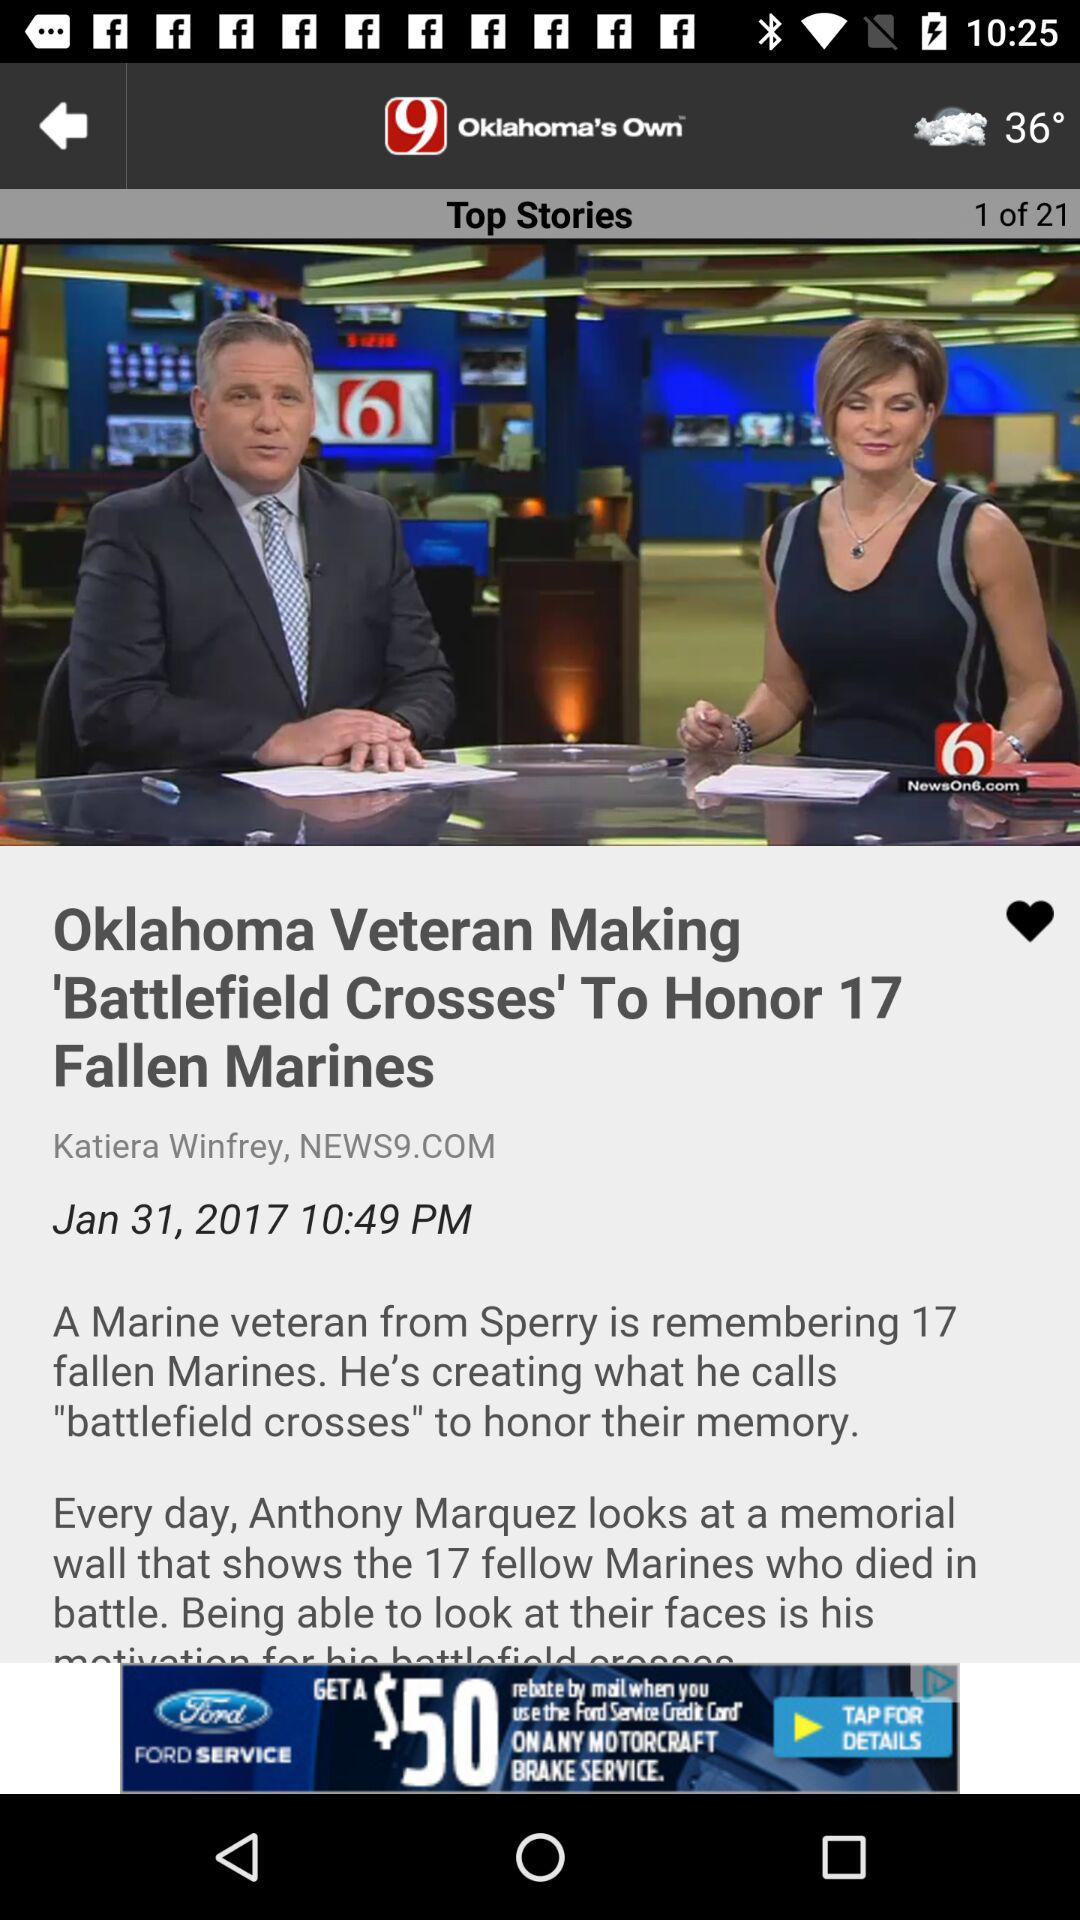What is the headline? The headline is "Oklahoma Veteran Making 'Battlefield Crosses' To Honor 17 Fallen Marines". 